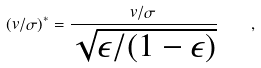<formula> <loc_0><loc_0><loc_500><loc_500>( v / \sigma ) ^ { * } = \frac { v / \sigma } { \sqrt { \epsilon / ( 1 - \epsilon ) } } \quad ,</formula> 